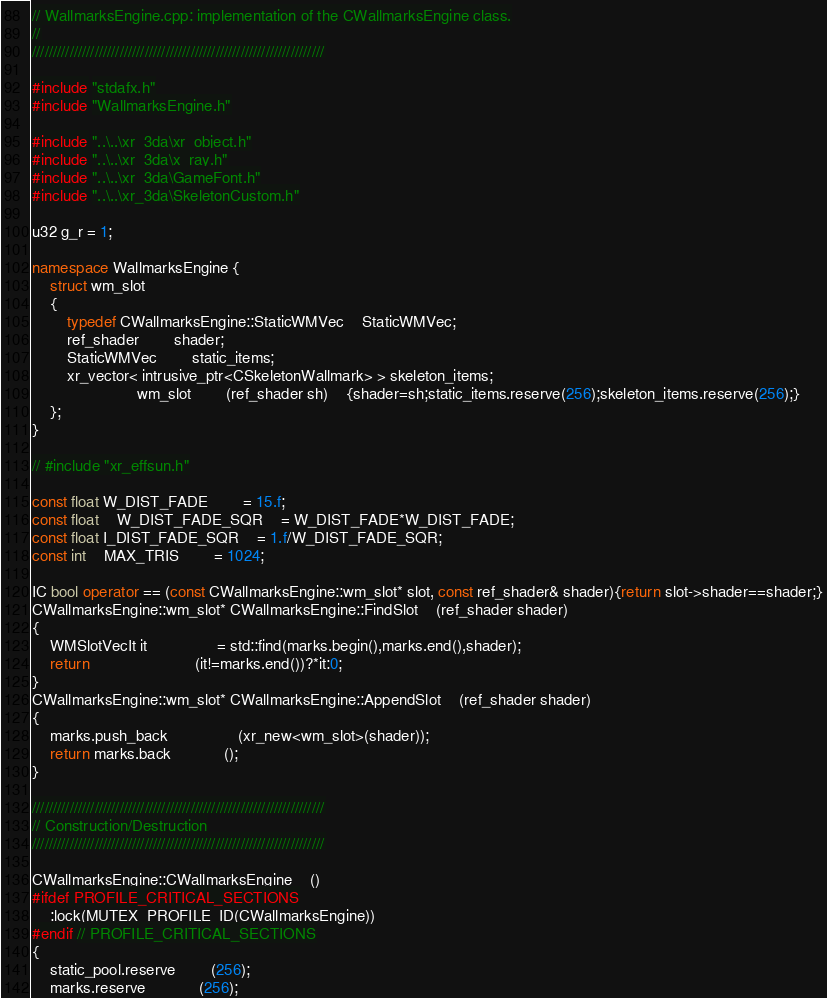<code> <loc_0><loc_0><loc_500><loc_500><_C++_>// WallmarksEngine.cpp: implementation of the CWallmarksEngine class.
//
//////////////////////////////////////////////////////////////////////

#include "stdafx.h"
#include "WallmarksEngine.h"

#include "..\..\xr_3da\xr_object.h"
#include "..\..\xr_3da\x_ray.h"
#include "..\..\xr_3da\GameFont.h"
#include "..\..\xr_3da\SkeletonCustom.h"

u32 g_r = 1;

namespace WallmarksEngine {
	struct wm_slot
	{
		typedef CWallmarksEngine::StaticWMVec	StaticWMVec;
		ref_shader		shader;
		StaticWMVec		static_items;
		xr_vector< intrusive_ptr<CSkeletonWallmark> > skeleton_items;
						wm_slot		(ref_shader sh)	{shader=sh;static_items.reserve(256);skeleton_items.reserve(256);}
	};
}

// #include "xr_effsun.h"

const float W_DIST_FADE		= 15.f;
const float	W_DIST_FADE_SQR	= W_DIST_FADE*W_DIST_FADE;
const float I_DIST_FADE_SQR	= 1.f/W_DIST_FADE_SQR;
const int	MAX_TRIS		= 1024;

IC bool operator == (const CWallmarksEngine::wm_slot* slot, const ref_shader& shader){return slot->shader==shader;}
CWallmarksEngine::wm_slot* CWallmarksEngine::FindSlot	(ref_shader shader)
{
	WMSlotVecIt it				= std::find(marks.begin(),marks.end(),shader);
	return						(it!=marks.end())?*it:0;
}
CWallmarksEngine::wm_slot* CWallmarksEngine::AppendSlot	(ref_shader shader)
{
	marks.push_back				(xr_new<wm_slot>(shader));
	return marks.back			();
}

//////////////////////////////////////////////////////////////////////
// Construction/Destruction
//////////////////////////////////////////////////////////////////////

CWallmarksEngine::CWallmarksEngine	()
#ifdef PROFILE_CRITICAL_SECTIONS
	:lock(MUTEX_PROFILE_ID(CWallmarksEngine))
#endif // PROFILE_CRITICAL_SECTIONS
{
	static_pool.reserve		(256);
	marks.reserve			(256);</code> 